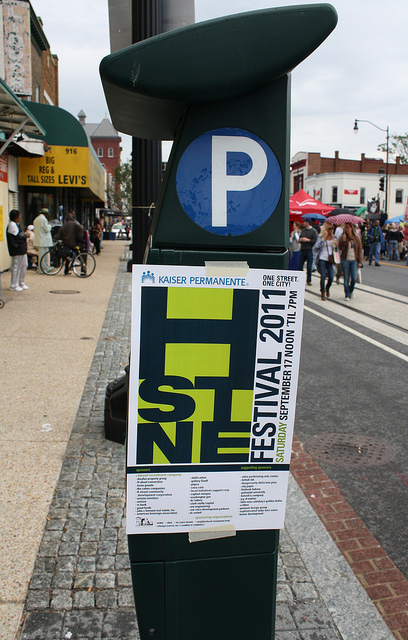Please extract the text content from this image. NE LEVI'S P 2011 FESTIVAL NOON SATURDAY SEPTEMBER 17 TIL 7PM ONE CITY STREET ONE PRRMANENTE KAISER 916 